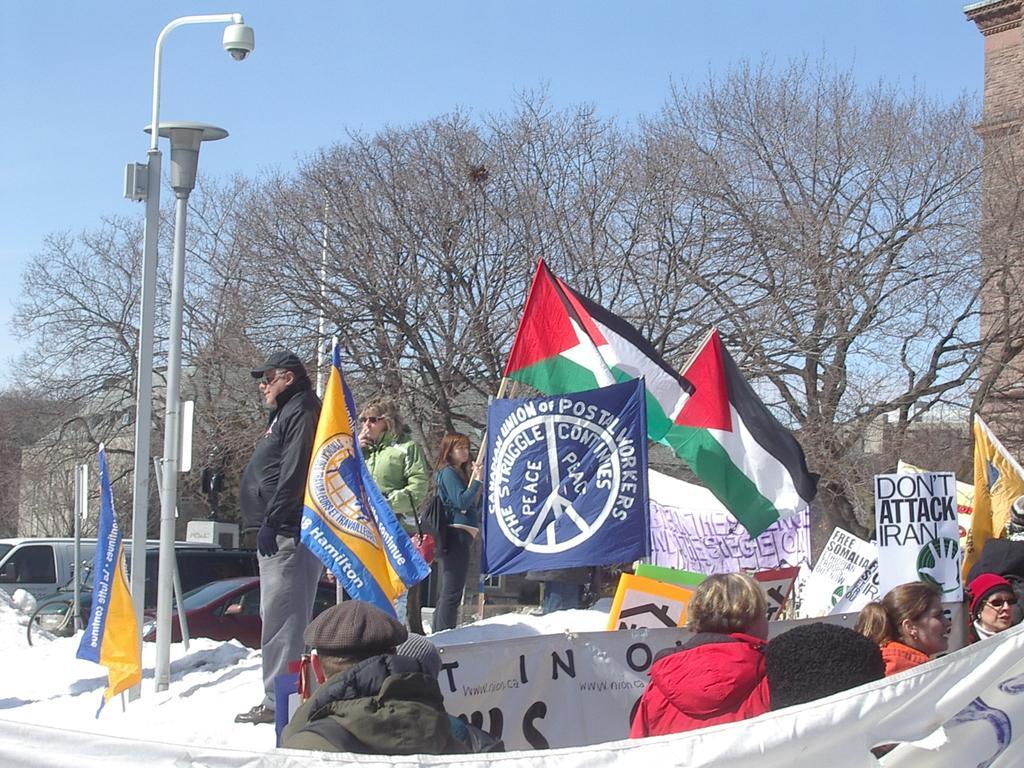Please provide a concise description of this image. In this image, we can see a group[ of people. Few are holding some objects. In this image, we can see flags, board, banners, vehicles, poles, trees, wall. Background there is a sky. 